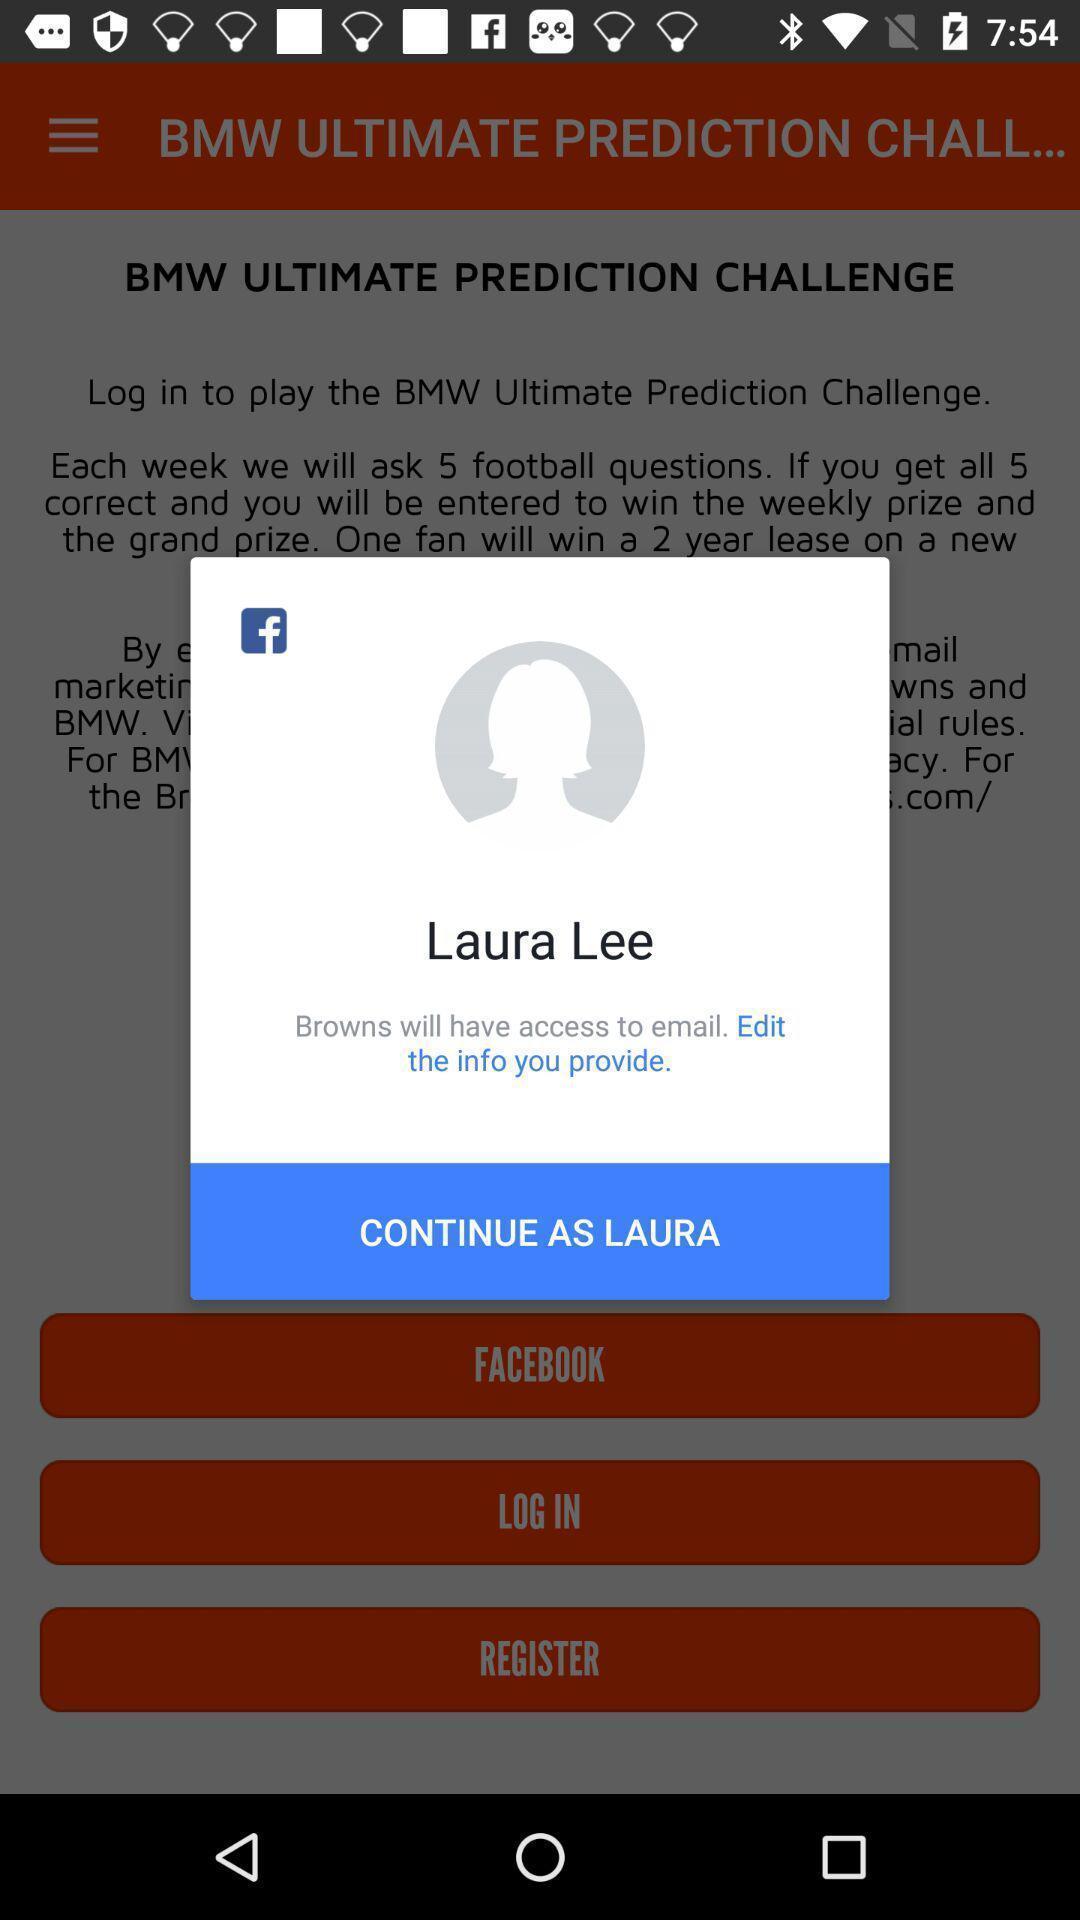What can you discern from this picture? Popup showing continue option. 